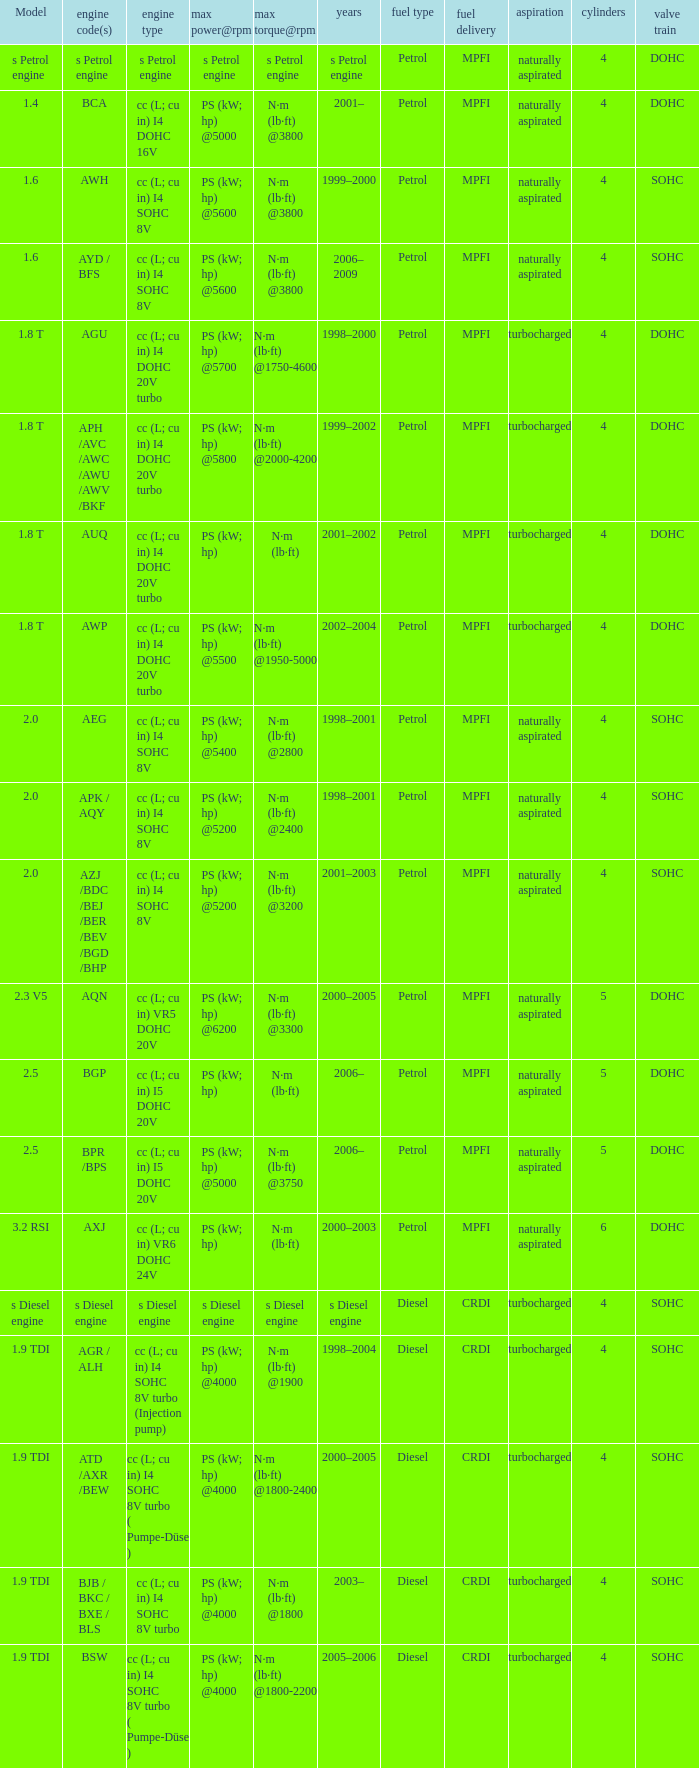For the engine with model 2.5 and a max power of ps (kw; hp) at 5000 rpm, what was the maximum torque and its associated rpm? N·m (lb·ft) @3750. 